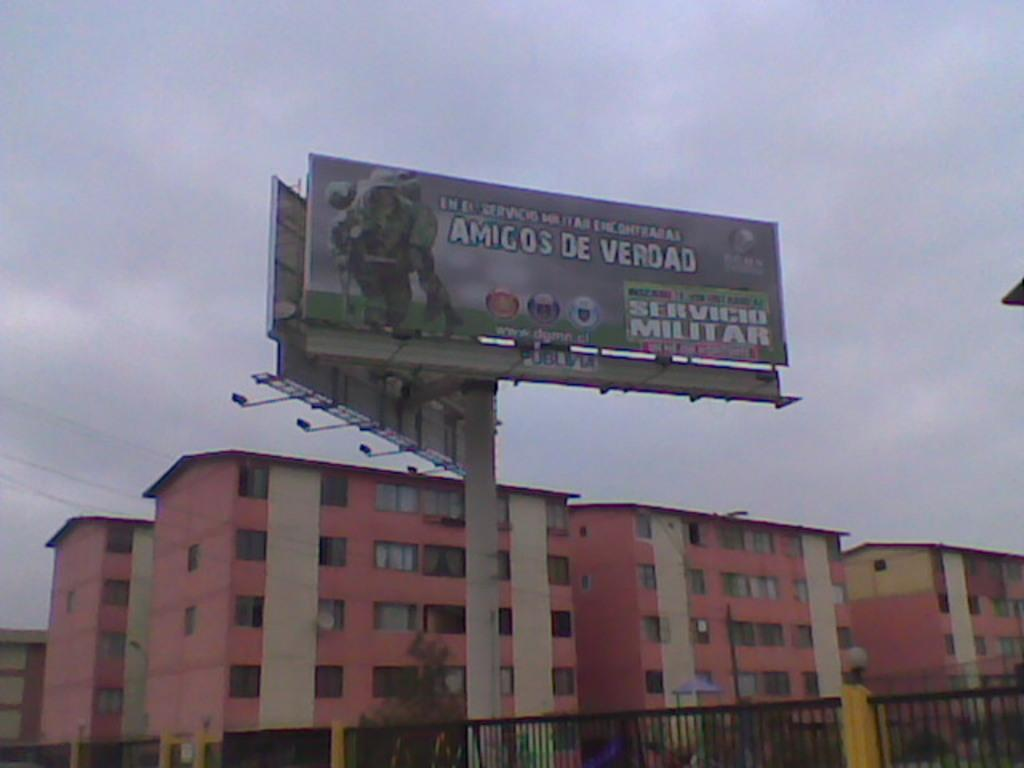Provide a one-sentence caption for the provided image. Apartment buildings sit beyond a billboard that displays a military ad that is written in Spanish. 